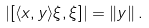<formula> <loc_0><loc_0><loc_500><loc_500>| [ \langle x , y \rangle \xi , \xi ] | = \left \| y \right \| .</formula> 